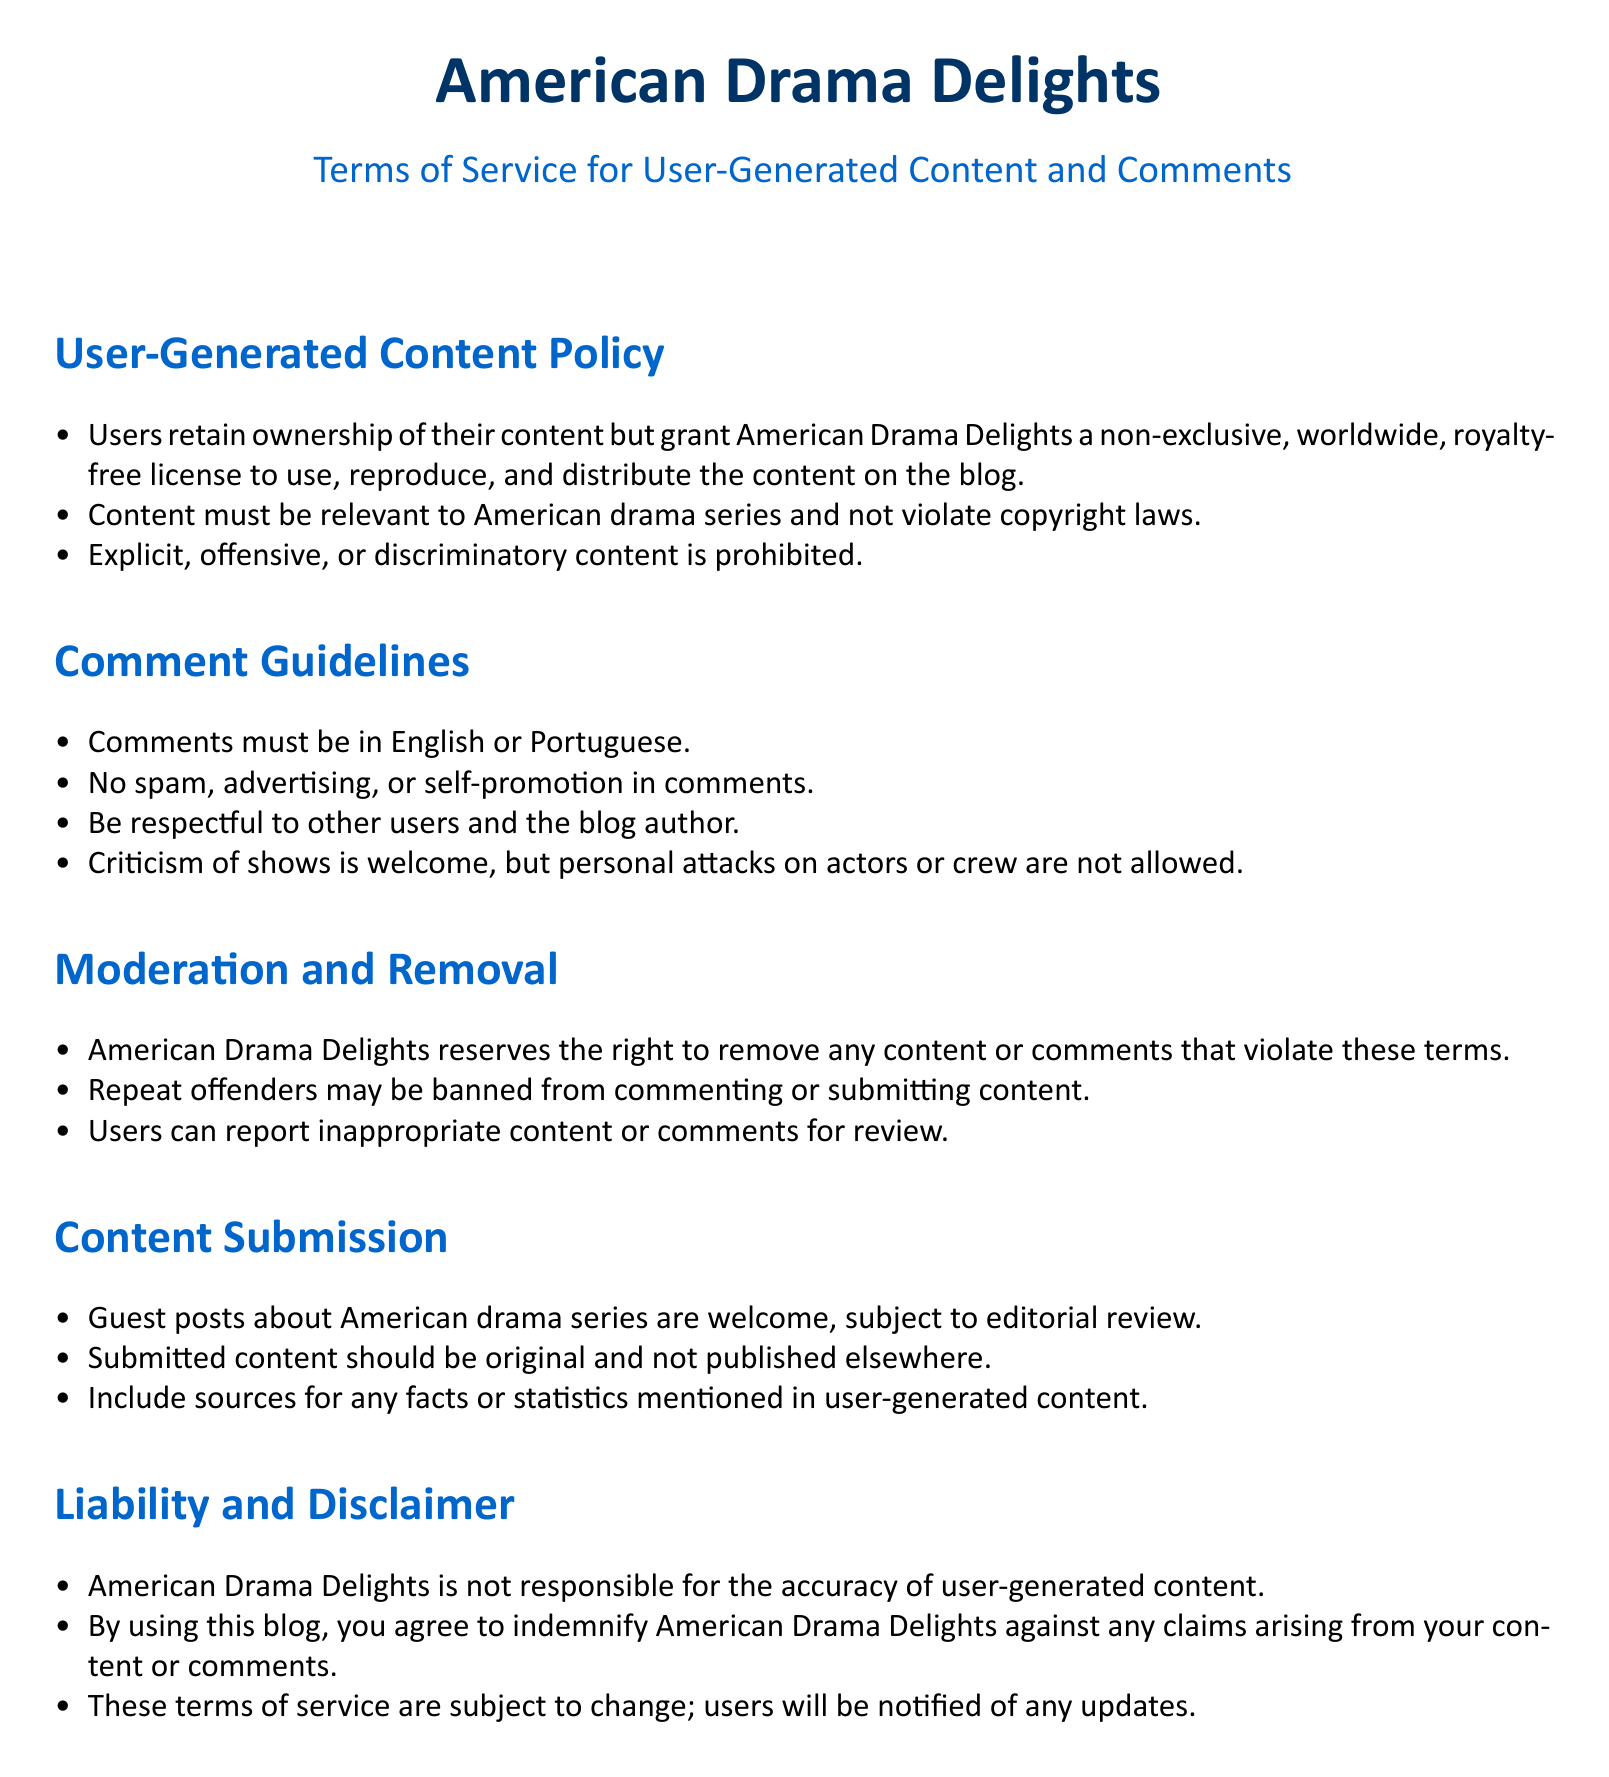what is the name of the blog? The title of the blog is mentioned at the top of the document.
Answer: American Drama Delights what languages are acceptable for comments? The document specifies the languages that can be used in comments.
Answer: English or Portuguese what type of content is prohibited? The document lists various types of content that cannot be submitted.
Answer: Explicit, offensive, or discriminatory content how many guidelines are listed under Comment Guidelines? The document provides a list of guidelines under the Comment section.
Answer: Four what should users do if they find inappropriate content? The document advises users on the action they can take regarding inappropriate content.
Answer: Report inappropriate content or comments for review what type of submissions are welcome? The document specifies the types of user submissions accepted by the blog.
Answer: Guest posts about American drama series who is responsible for the accuracy of user-generated content? The document addresses the liability related to user-generated content.
Answer: American Drama Delights how will users be informed about changes to the terms? The document describes the procedure for notifying users about changes.
Answer: Users will be notified of any updates 